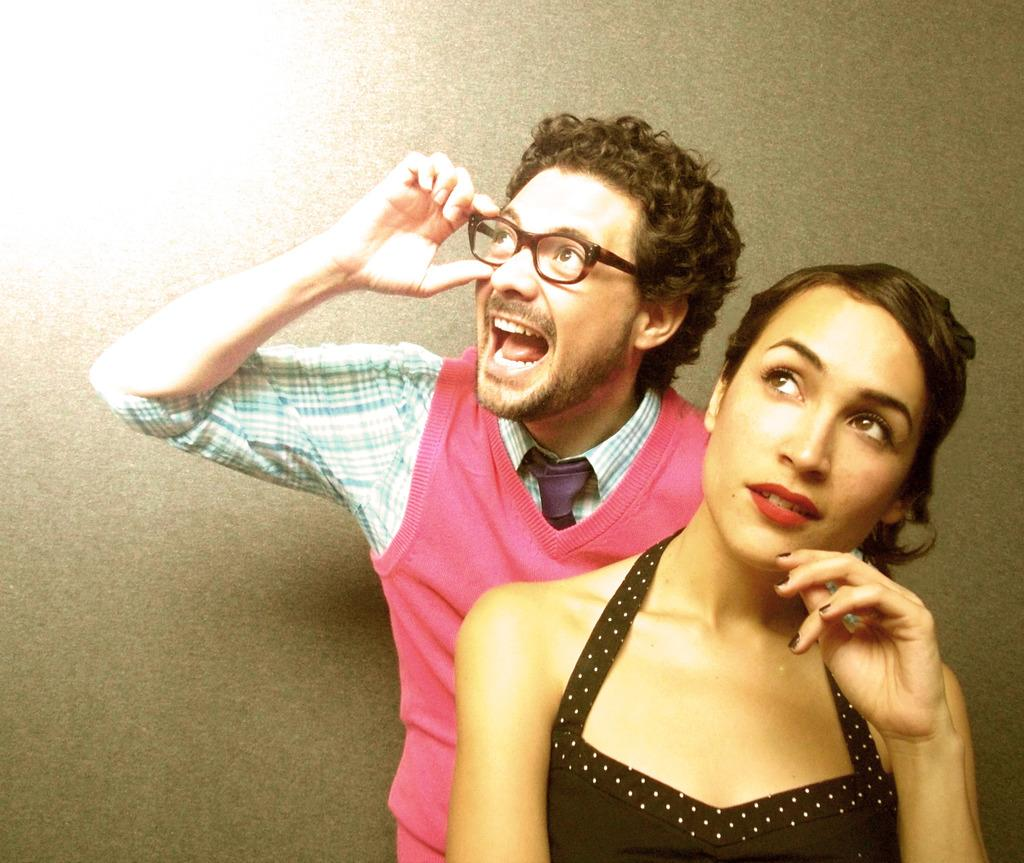How many people are present in the image? There are two people in the image, a man and a woman. What is the color of the background in the image? The background of the image has a grey color. Can you describe the lighting in the image? There is light visible in the background of the image. How long does it take for the fork to reach the park in the image? There is no fork or park present in the image, so this question cannot be answered. 